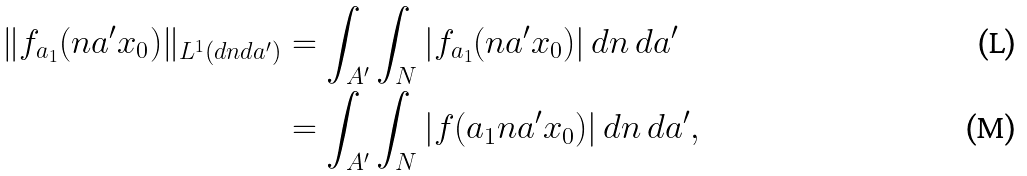<formula> <loc_0><loc_0><loc_500><loc_500>\| f _ { a _ { 1 } } ( n a ^ { \prime } x _ { 0 } ) \| _ { L ^ { 1 } ( d n d a ^ { \prime } ) } & = \int _ { A ^ { \prime } } \int _ { N } | f _ { a _ { 1 } } ( n a ^ { \prime } x _ { 0 } ) | \, d n \, d a ^ { \prime } \\ & = \int _ { A ^ { \prime } } \int _ { N } | f ( a _ { 1 } n a ^ { \prime } x _ { 0 } ) | \, d n \, d a ^ { \prime } ,</formula> 